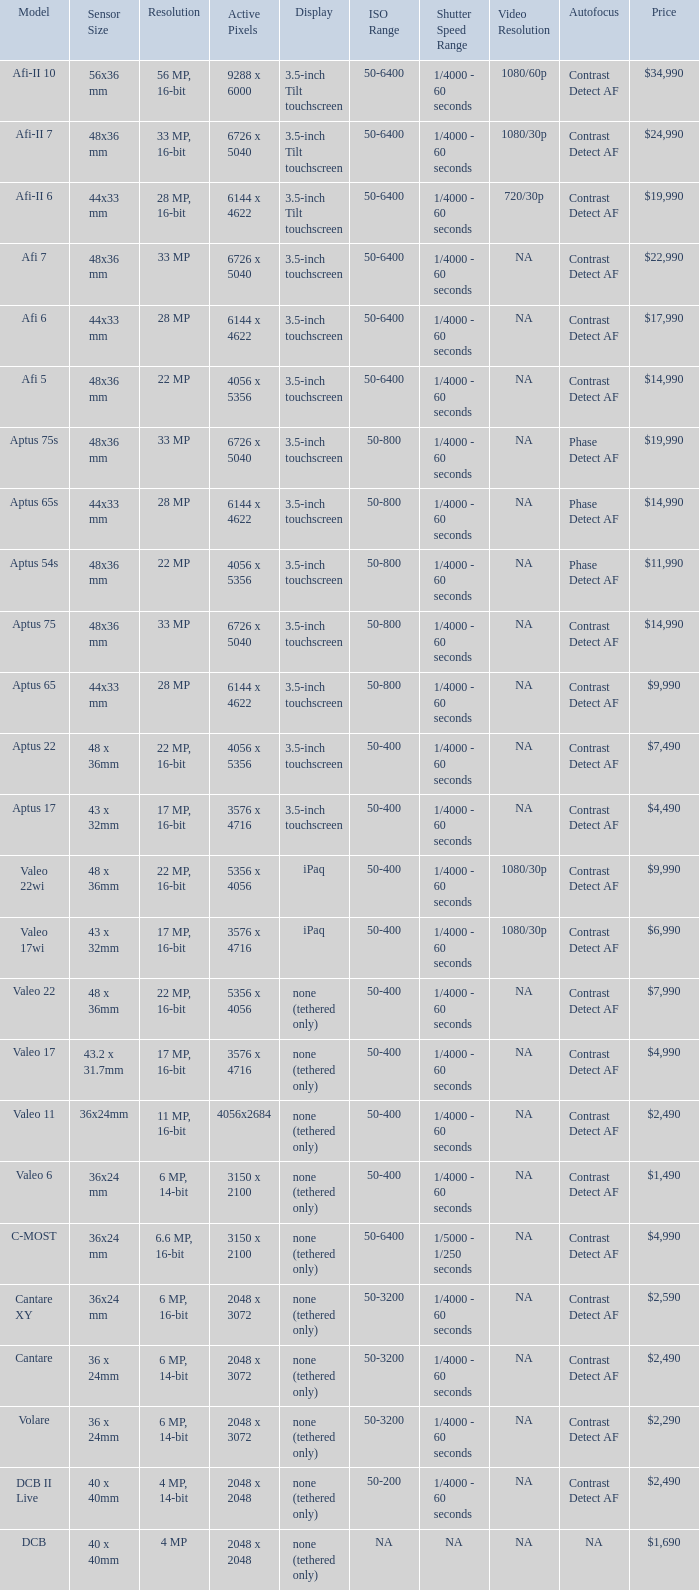What are the active pixels of the c-most model camera? 3150 x 2100. 